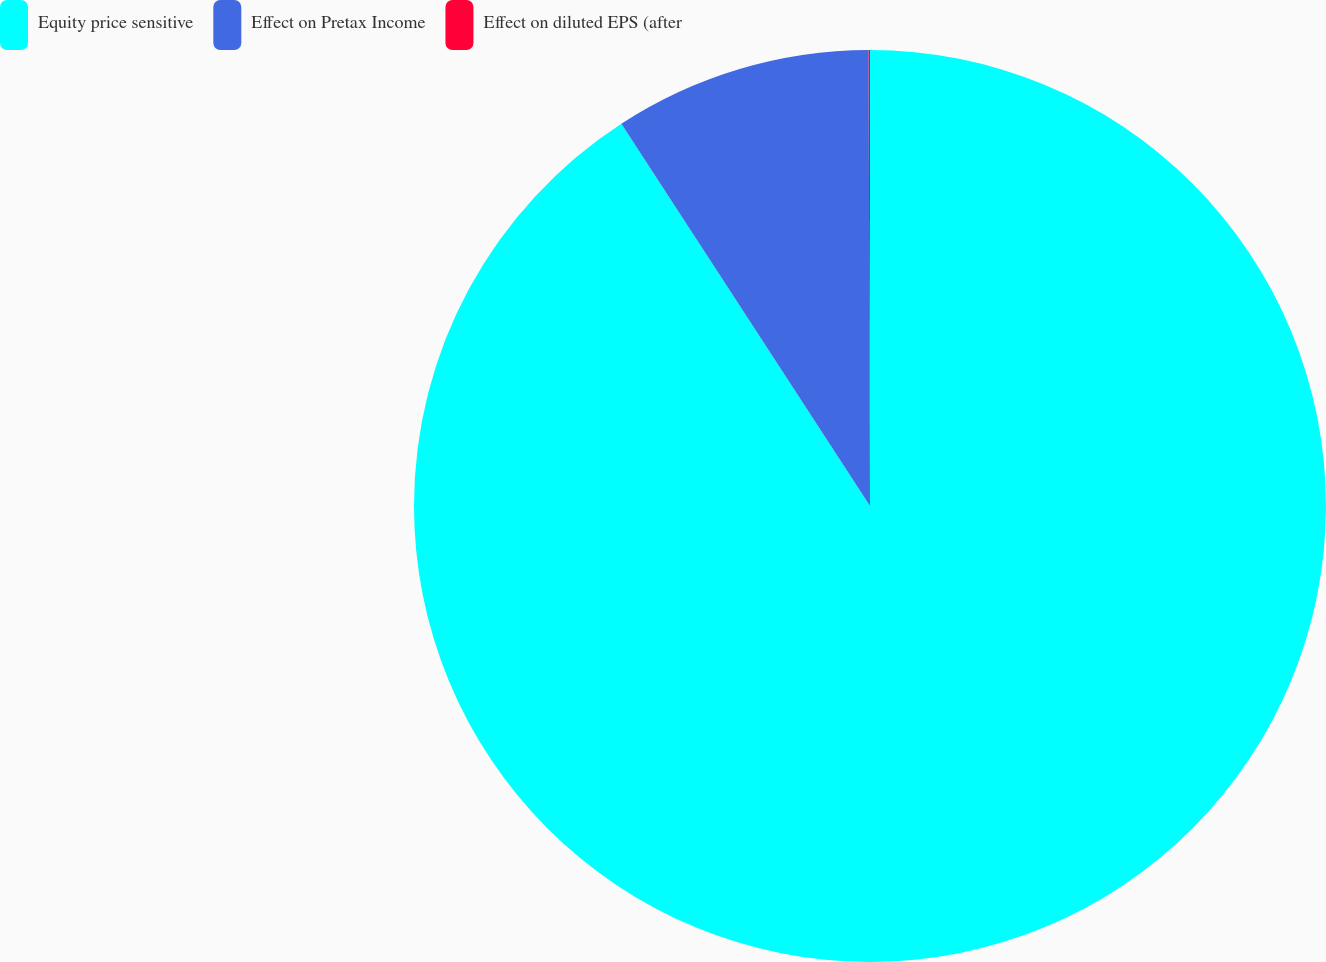<chart> <loc_0><loc_0><loc_500><loc_500><pie_chart><fcel>Equity price sensitive<fcel>Effect on Pretax Income<fcel>Effect on diluted EPS (after<nl><fcel>90.82%<fcel>9.13%<fcel>0.05%<nl></chart> 